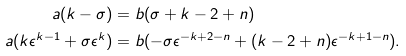<formula> <loc_0><loc_0><loc_500><loc_500>a ( k - \sigma ) & = b ( \sigma + k - 2 + n ) \\ a ( k \epsilon ^ { k - 1 } + \sigma \epsilon ^ { k } ) & = b ( - \sigma \epsilon ^ { - k + 2 - n } + ( k - 2 + n ) \epsilon ^ { - k + 1 - n } ) .</formula> 